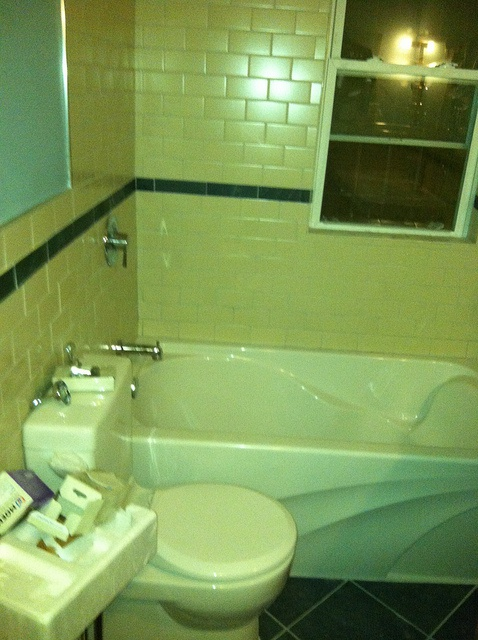Describe the objects in this image and their specific colors. I can see toilet in teal, lightgreen, and olive tones and sink in teal, lightgreen, and lightyellow tones in this image. 